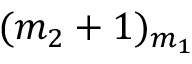<formula> <loc_0><loc_0><loc_500><loc_500>( m _ { 2 } + 1 ) _ { m _ { 1 } }</formula> 